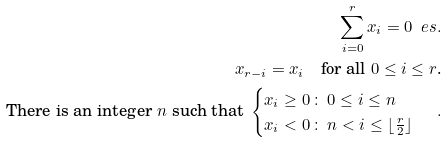Convert formula to latex. <formula><loc_0><loc_0><loc_500><loc_500>\sum _ { i = 0 } ^ { r } x _ { i } = 0 \ e s . \\ x _ { r - i } = x _ { i } \quad \text {for all\/ $0 \leq i \leq r$.} \\ \text {There is an integer\/ $n$ such that } \begin{cases} x _ { i } \geq 0 \, \colon \, 0 \leq i \leq n \\ x _ { i } < 0 \, \colon \, n < i \leq \lfloor \frac { r } { 2 } \rfloor \end{cases} \, .</formula> 